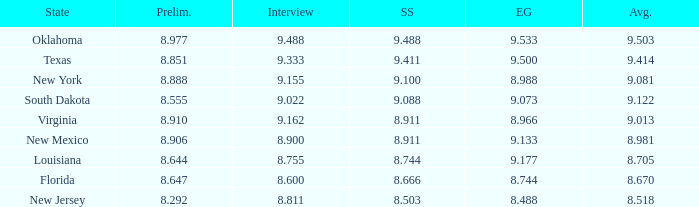 what's the evening gown where preliminaries is 8.977 9.533. 